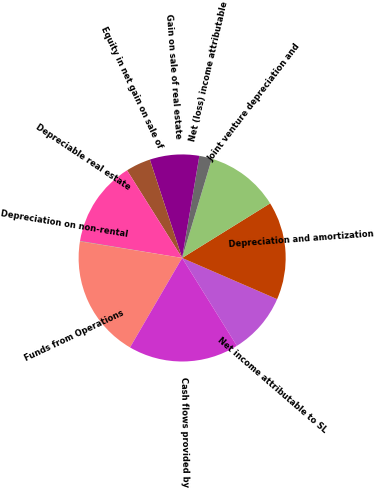<chart> <loc_0><loc_0><loc_500><loc_500><pie_chart><fcel>Net income attributable to SL<fcel>Depreciation and amortization<fcel>Joint venture depreciation and<fcel>Net (loss) income attributable<fcel>Gain on sale of real estate<fcel>Equity in net gain on sale of<fcel>Depreciable real estate<fcel>Depreciation on non-rental<fcel>Funds from Operations<fcel>Cash flows provided by<nl><fcel>9.62%<fcel>15.35%<fcel>11.53%<fcel>1.97%<fcel>7.71%<fcel>3.88%<fcel>13.44%<fcel>0.06%<fcel>19.17%<fcel>17.26%<nl></chart> 